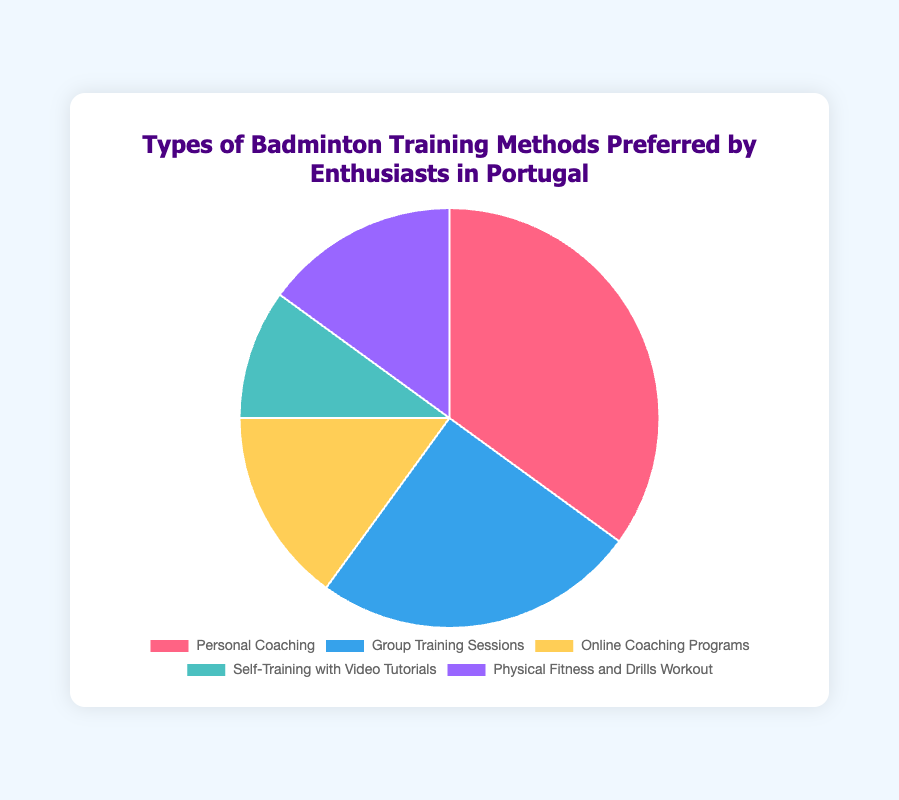What percentage of enthusiasts prefer Personal Coaching? Identify the segment labeled "Personal Coaching" in the pie chart. The data indicates that 35% of enthusiasts prefer this method.
Answer: 35% Which training method is least preferred? Observe that the smallest segment in the pie chart corresponds to "Self-Training with Video Tutorials," which also has the smallest value in the data at 10%.
Answer: Self-Training with Video Tutorials How does the preference for Group Training Sessions compare to Online Coaching Programs? Compare the values for "Group Training Sessions" (25%) and "Online Coaching Programs" (15%). Group Training Sessions are preferred by 10% more enthusiasts.
Answer: Group Training Sessions are preferred 10% more What is the combined percentage of enthusiasts preferring Online Coaching Programs and Physical Fitness and Drills Workout? Sum the percentages for "Online Coaching Programs" (15%) and "Physical Fitness and Drills Workout" (15%). The combined preference is 15% + 15% = 30%.
Answer: 30% Which training method is represented by the blue segment? Identify the color segments in the pie chart. The blue segment corresponds to "Group Training Sessions," which aligns with the provided color information.
Answer: Group Training Sessions What is the difference in preference between Physical Fitness and Drills Workout and Self-Training with Video Tutorials? Subtract the percentage of "Self-Training with Video Tutorials" (10%) from "Physical Fitness and Drills Workout" (15%), resulting in a 5% difference.
Answer: 5% What is the average preference percentage for all training methods? Sum all the preferences: 35% + 25% + 15% + 10% + 15% = 100%. Then divide by the number of methods (5): 100% / 5 = 20%.
Answer: 20% Which two training methods have an equal percentage of preference? Identify the methods with the same value: both "Online Coaching Programs" and "Physical Fitness and Drills Workout" have 15%.
Answer: Online Coaching Programs and Physical Fitness and Drills Workout 